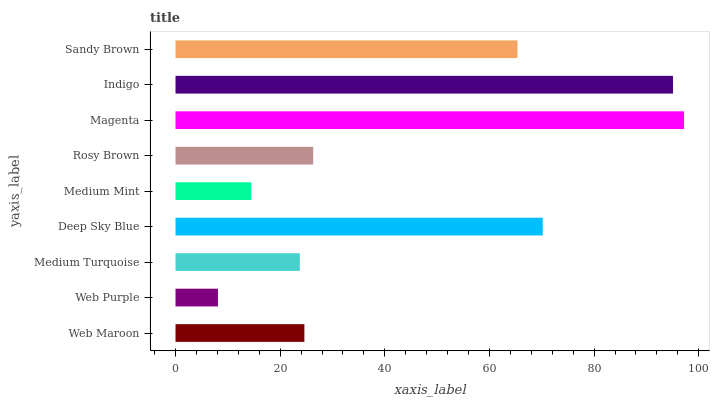Is Web Purple the minimum?
Answer yes or no. Yes. Is Magenta the maximum?
Answer yes or no. Yes. Is Medium Turquoise the minimum?
Answer yes or no. No. Is Medium Turquoise the maximum?
Answer yes or no. No. Is Medium Turquoise greater than Web Purple?
Answer yes or no. Yes. Is Web Purple less than Medium Turquoise?
Answer yes or no. Yes. Is Web Purple greater than Medium Turquoise?
Answer yes or no. No. Is Medium Turquoise less than Web Purple?
Answer yes or no. No. Is Rosy Brown the high median?
Answer yes or no. Yes. Is Rosy Brown the low median?
Answer yes or no. Yes. Is Deep Sky Blue the high median?
Answer yes or no. No. Is Medium Mint the low median?
Answer yes or no. No. 